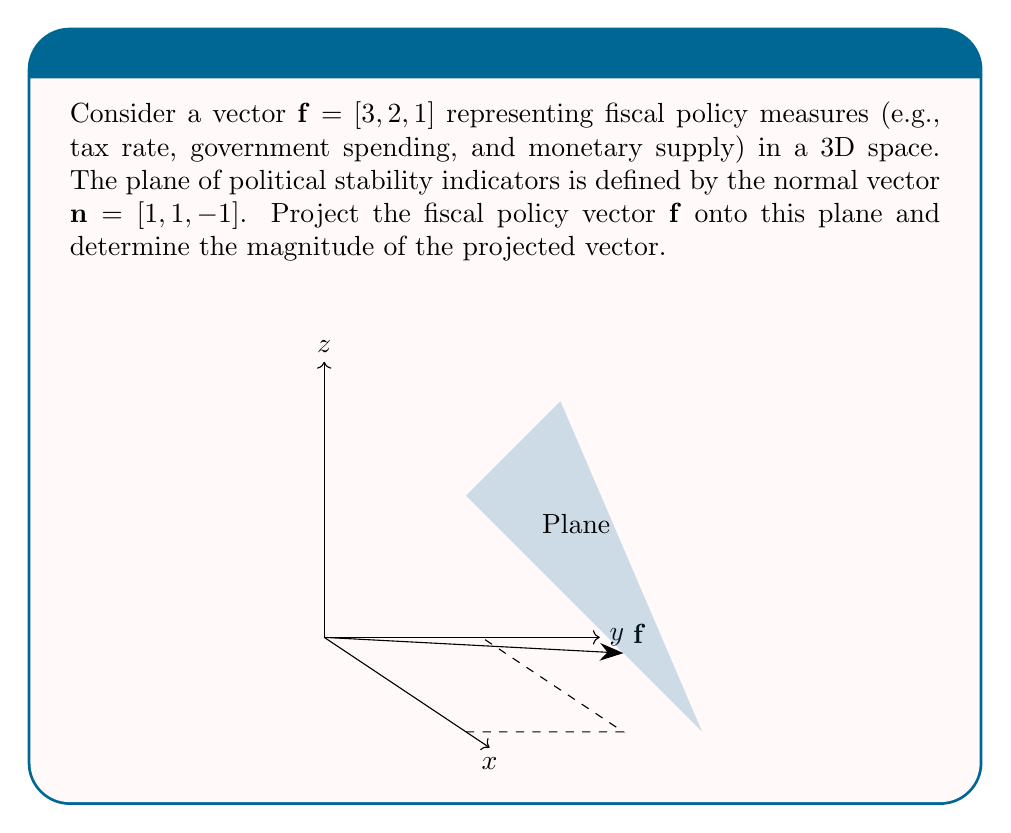Can you answer this question? Let's approach this step-by-step:

1) The formula for vector projection onto a plane is:
   $$\mathbf{f}_{\text{proj}} = \mathbf{f} - \frac{\mathbf{f} \cdot \mathbf{n}}{\|\mathbf{n}\|^2} \mathbf{n}$$

2) First, calculate the dot product $\mathbf{f} \cdot \mathbf{n}$:
   $$\mathbf{f} \cdot \mathbf{n} = 3(1) + 2(1) + 1(-1) = 4$$

3) Calculate $\|\mathbf{n}\|^2$:
   $$\|\mathbf{n}\|^2 = 1^2 + 1^2 + (-1)^2 = 3$$

4) Now, calculate $\frac{\mathbf{f} \cdot \mathbf{n}}{\|\mathbf{n}\|^2} \mathbf{n}$:
   $$\frac{4}{3} [1, 1, -1] = [\frac{4}{3}, \frac{4}{3}, -\frac{4}{3}]$$

5) Subtract this from $\mathbf{f}$:
   $$\mathbf{f}_{\text{proj}} = [3, 2, 1] - [\frac{4}{3}, \frac{4}{3}, -\frac{4}{3}] = [\frac{5}{3}, \frac{2}{3}, \frac{7}{3}]$$

6) To find the magnitude of $\mathbf{f}_{\text{proj}}$, use the Pythagorean theorem:
   $$\|\mathbf{f}_{\text{proj}}\| = \sqrt{(\frac{5}{3})^2 + (\frac{2}{3})^2 + (\frac{7}{3})^2}$$

7) Simplify:
   $$\|\mathbf{f}_{\text{proj}}\| = \sqrt{\frac{25}{9} + \frac{4}{9} + \frac{49}{9}} = \sqrt{\frac{78}{9}} = \frac{\sqrt{78}}{3}$$
Answer: $\frac{\sqrt{78}}{3}$ 